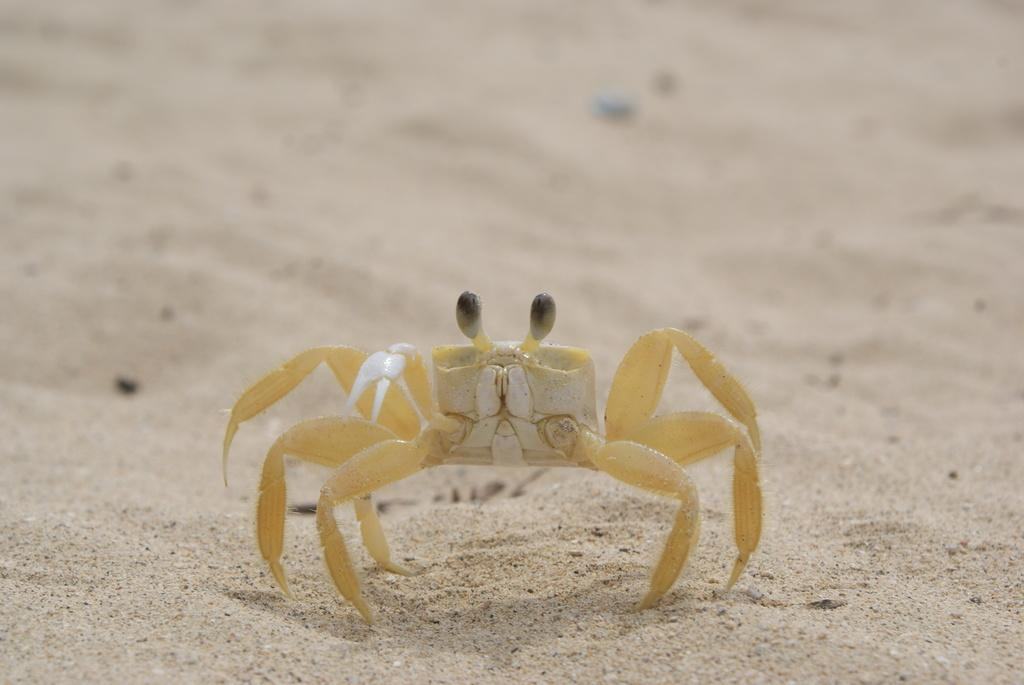What is the primary element in the image? The image consists of sand. What type of living organism can be seen in the image? There is an insect in the image. Where is the insect located in the image? The insect is in the middle of the image. What color is the insect in the image? The insect is yellow in color. Can you tell me how many dogs are playing a guitar in the image? There are no dogs or guitars present in the image. What type of secretary can be seen working in the image? There is no secretary present in the image. 